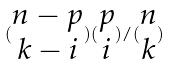<formula> <loc_0><loc_0><loc_500><loc_500>( \begin{matrix} n - p \\ k - i \end{matrix} ) ( \begin{matrix} p \\ i \end{matrix} ) / ( \begin{matrix} n \\ k \end{matrix} )</formula> 